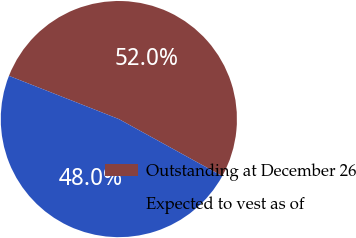Convert chart. <chart><loc_0><loc_0><loc_500><loc_500><pie_chart><fcel>Outstanding at December 26<fcel>Expected to vest as of<nl><fcel>52.05%<fcel>47.95%<nl></chart> 